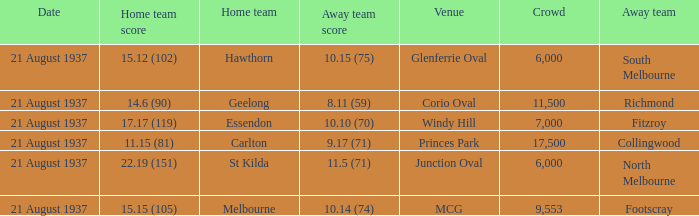Where does South Melbourne play? Glenferrie Oval. Could you parse the entire table? {'header': ['Date', 'Home team score', 'Home team', 'Away team score', 'Venue', 'Crowd', 'Away team'], 'rows': [['21 August 1937', '15.12 (102)', 'Hawthorn', '10.15 (75)', 'Glenferrie Oval', '6,000', 'South Melbourne'], ['21 August 1937', '14.6 (90)', 'Geelong', '8.11 (59)', 'Corio Oval', '11,500', 'Richmond'], ['21 August 1937', '17.17 (119)', 'Essendon', '10.10 (70)', 'Windy Hill', '7,000', 'Fitzroy'], ['21 August 1937', '11.15 (81)', 'Carlton', '9.17 (71)', 'Princes Park', '17,500', 'Collingwood'], ['21 August 1937', '22.19 (151)', 'St Kilda', '11.5 (71)', 'Junction Oval', '6,000', 'North Melbourne'], ['21 August 1937', '15.15 (105)', 'Melbourne', '10.14 (74)', 'MCG', '9,553', 'Footscray']]} 